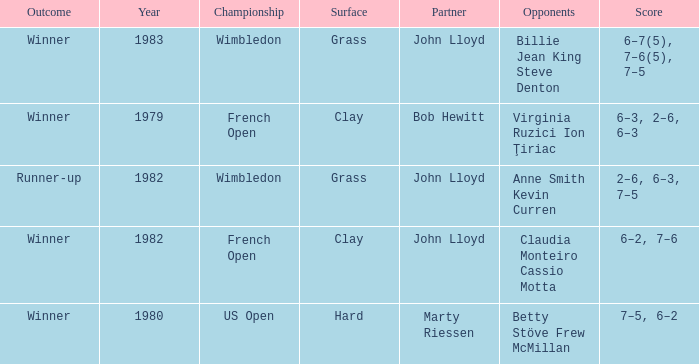Who were the opponents that led to an outcome of winner on a grass surface? Billie Jean King Steve Denton. 